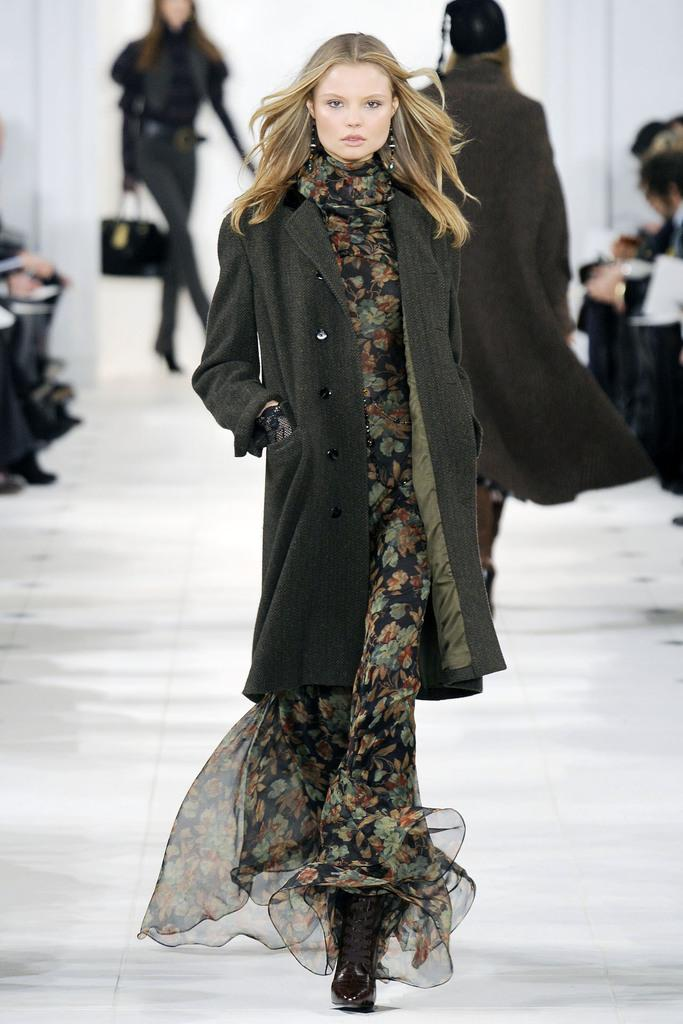Who is the main subject in the image? There is a woman in the image. What is the woman doing in the image? The woman is standing. What is the woman wearing in the image? The woman is wearing a black coat and a dress with different colors. Can you describe the background of the image? There are people visible in the background. What color is the floor in the image? The floor is white. What type of bomb is the woman holding in the image? There is no bomb present in the image; the woman is not holding anything. 